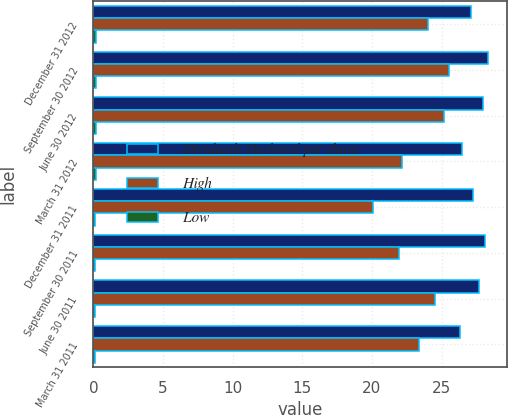Convert chart. <chart><loc_0><loc_0><loc_500><loc_500><stacked_bar_chart><ecel><fcel>December 31 2012<fcel>September 30 2012<fcel>June 30 2012<fcel>March 31 2012<fcel>December 31 2011<fcel>September 30 2011<fcel>June 30 2011<fcel>March 31 2011<nl><fcel>Dividends Declared per share<fcel>27.13<fcel>28.3<fcel>27.98<fcel>26.44<fcel>27.26<fcel>28.12<fcel>27.67<fcel>26.33<nl><fcel>High<fcel>24.05<fcel>25.52<fcel>25.17<fcel>22.19<fcel>20.08<fcel>21.92<fcel>24.5<fcel>23.38<nl><fcel>Low<fcel>0.2<fcel>0.2<fcel>0.18<fcel>0.18<fcel>0.12<fcel>0.12<fcel>0.12<fcel>0.12<nl></chart> 